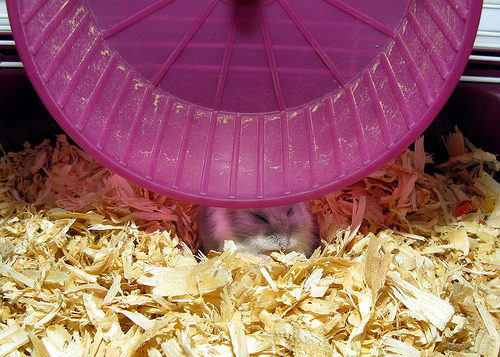<image>
Is the wheel on the gerbil? Yes. Looking at the image, I can see the wheel is positioned on top of the gerbil, with the gerbil providing support. 